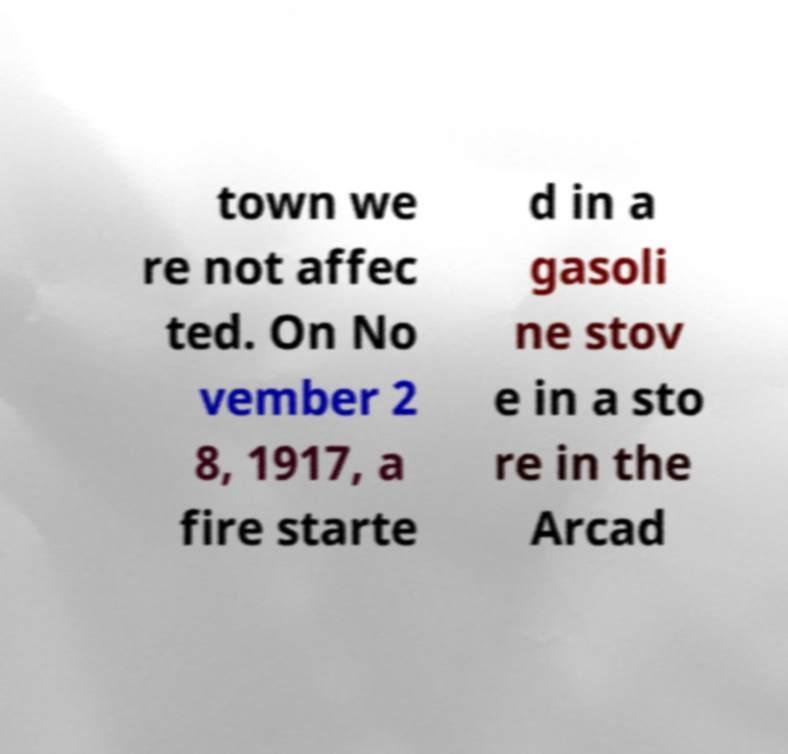Can you read and provide the text displayed in the image?This photo seems to have some interesting text. Can you extract and type it out for me? town we re not affec ted. On No vember 2 8, 1917, a fire starte d in a gasoli ne stov e in a sto re in the Arcad 